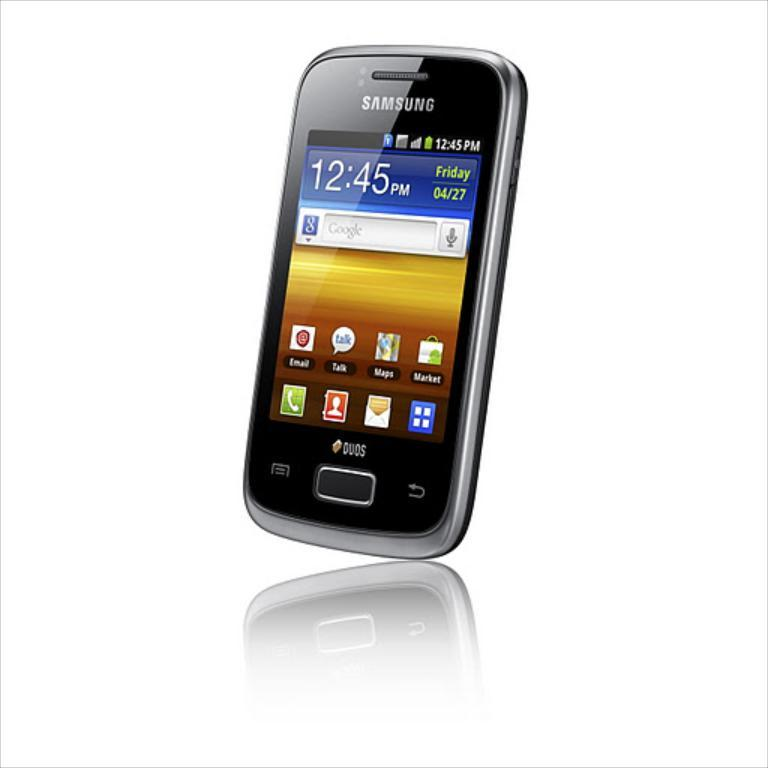<image>
Provide a brief description of the given image. A Samsung Duos on the home screen, reading Friday 4/27 at 12:45pm. 